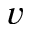Convert formula to latex. <formula><loc_0><loc_0><loc_500><loc_500>v</formula> 